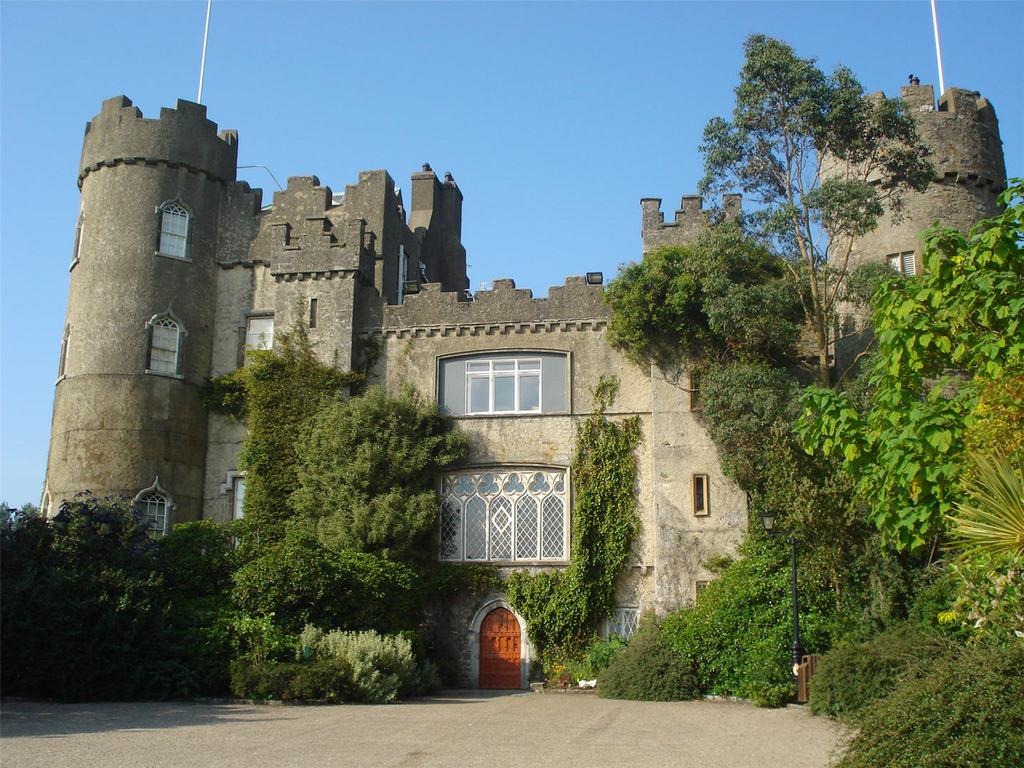What type of structure is present in the image? There is a building in the image. What features can be seen on the building? The building has windows and a door. Are there any natural elements near the building? Yes, there are plants and trees near the building. What can be seen in the background of the image? The sky is visible in the background of the image. What type of debt is being discussed by the writer in the image? There is no writer or discussion of debt present in the image. How does the neck of the person in the image look? There is no person present in the image, so it is not possible to describe their neck. 